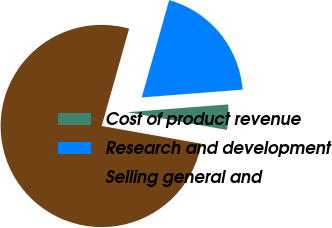Convert chart. <chart><loc_0><loc_0><loc_500><loc_500><pie_chart><fcel>Cost of product revenue<fcel>Research and development<fcel>Selling general and<nl><fcel>4.03%<fcel>19.4%<fcel>76.57%<nl></chart> 